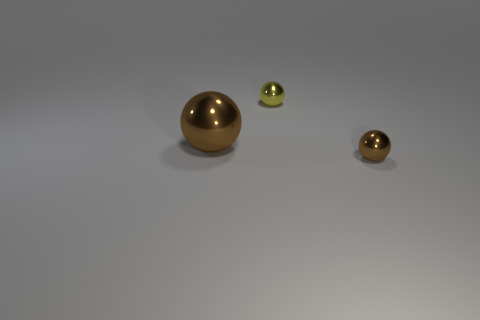Add 2 large yellow matte things. How many objects exist? 5 Subtract all green spheres. Subtract all large brown things. How many objects are left? 2 Add 1 brown metal objects. How many brown metal objects are left? 3 Add 2 small yellow objects. How many small yellow objects exist? 3 Subtract 0 green cylinders. How many objects are left? 3 